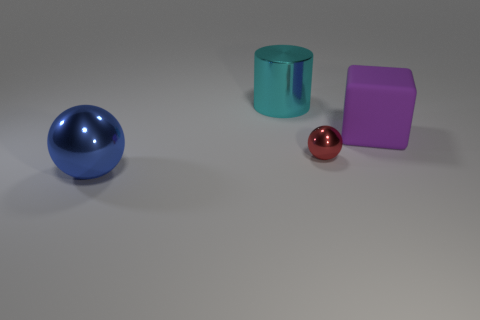How many large green matte balls are there?
Your answer should be compact. 0. Does the large shiny ball have the same color as the large metallic cylinder?
Provide a succinct answer. No. Is the number of big objects left of the purple block less than the number of big matte cubes in front of the big blue metallic object?
Your answer should be very brief. No. The big block is what color?
Keep it short and to the point. Purple. How many other large cylinders have the same color as the large cylinder?
Give a very brief answer. 0. There is a red sphere; are there any metal objects in front of it?
Your response must be concise. Yes. Is the number of large blue metal things that are behind the big cyan thing the same as the number of big purple cubes that are behind the rubber object?
Give a very brief answer. Yes. Do the metallic thing behind the matte block and the thing that is on the right side of the red shiny sphere have the same size?
Provide a succinct answer. Yes. What shape is the big object to the right of the metallic ball that is to the right of the large object that is in front of the tiny red object?
Provide a short and direct response. Cube. Are there any other things that are the same material as the tiny red object?
Offer a terse response. Yes. 